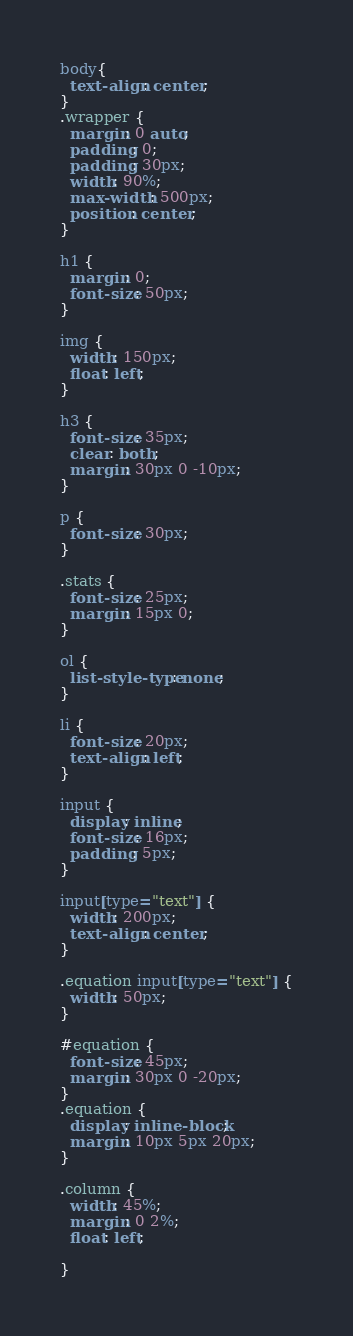Convert code to text. <code><loc_0><loc_0><loc_500><loc_500><_CSS_>body{
  text-align: center;
}
.wrapper {
  margin: 0 auto;
  padding: 0;
  padding: 30px;
  width: 90%;
  max-width: 500px;
  position: center;
}

h1 {
  margin: 0;
  font-size: 50px;
}

img {
  width: 150px;
  float: left;
}

h3 {
  font-size: 35px;
  clear: both;
  margin: 30px 0 -10px;
}

p {
  font-size: 30px;
}

.stats {
  font-size: 25px;
  margin: 15px 0;
}

ol {
  list-style-type: none;
}

li {
  font-size: 20px;
  text-align: left;
}

input {
  display: inline;
  font-size: 16px;
  padding: 5px;
}

input[type="text"] {
  width: 200px;
  text-align: center;
}

.equation input[type="text"] {
  width: 50px;
}

#equation {
  font-size: 45px;
  margin: 30px 0 -20px;
}
.equation {
  display: inline-block;
  margin: 10px 5px 20px;
}

.column {
  width: 45%;
  margin: 0 2%;
  float: left;

}</code> 